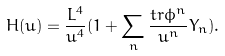<formula> <loc_0><loc_0><loc_500><loc_500>H ( u ) = \frac { L ^ { 4 } } { u ^ { 4 } } ( 1 + \sum _ { n } \frac { t r \phi ^ { n } } { u ^ { n } } Y _ { n } ) .</formula> 